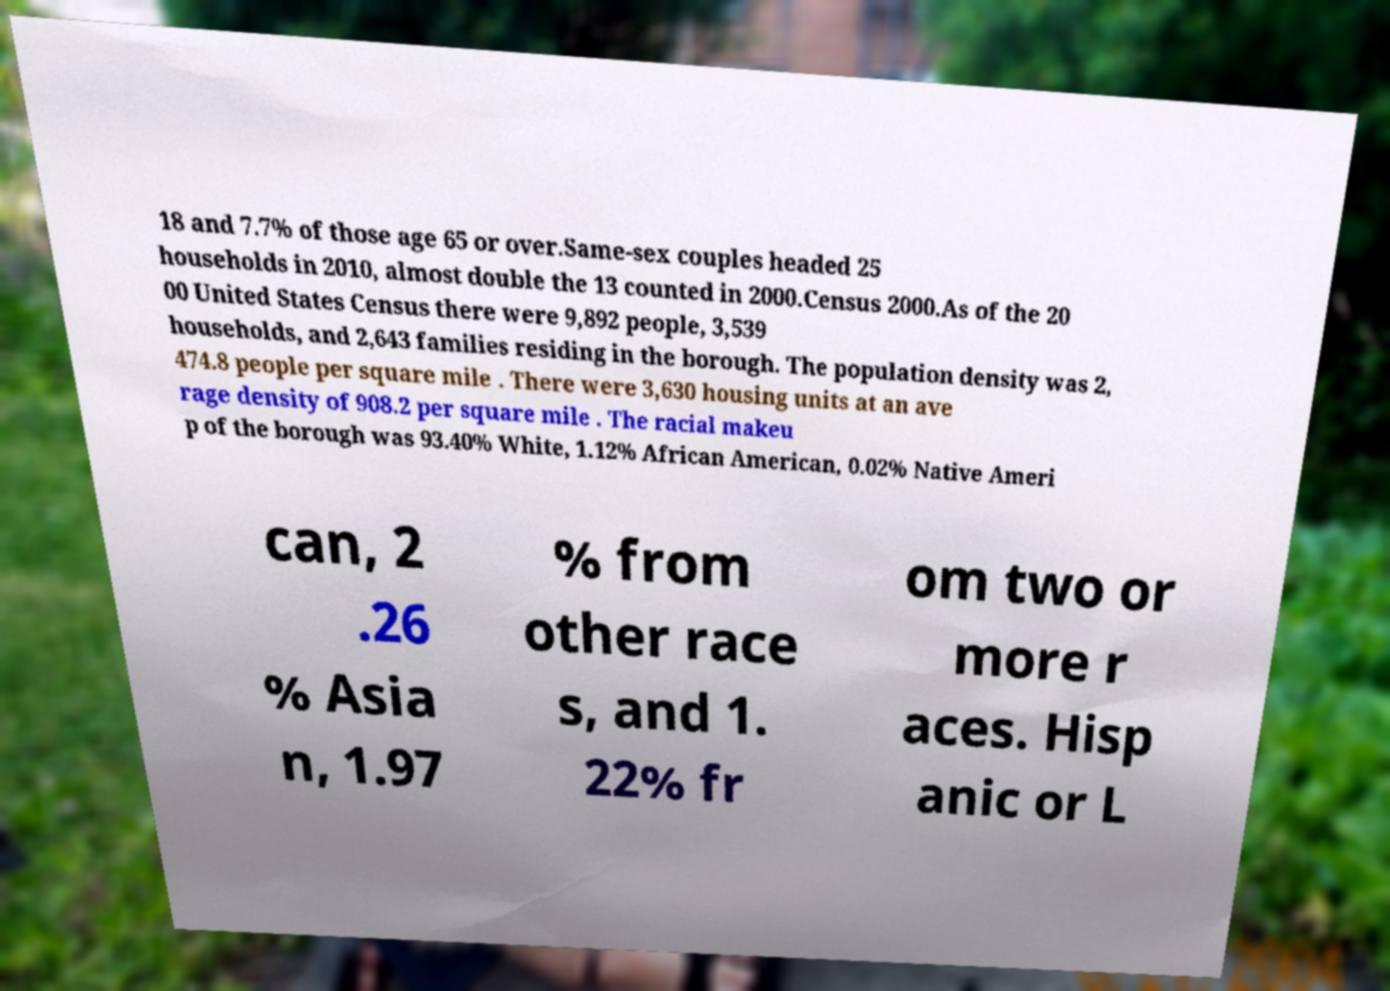Could you extract and type out the text from this image? 18 and 7.7% of those age 65 or over.Same-sex couples headed 25 households in 2010, almost double the 13 counted in 2000.Census 2000.As of the 20 00 United States Census there were 9,892 people, 3,539 households, and 2,643 families residing in the borough. The population density was 2, 474.8 people per square mile . There were 3,630 housing units at an ave rage density of 908.2 per square mile . The racial makeu p of the borough was 93.40% White, 1.12% African American, 0.02% Native Ameri can, 2 .26 % Asia n, 1.97 % from other race s, and 1. 22% fr om two or more r aces. Hisp anic or L 